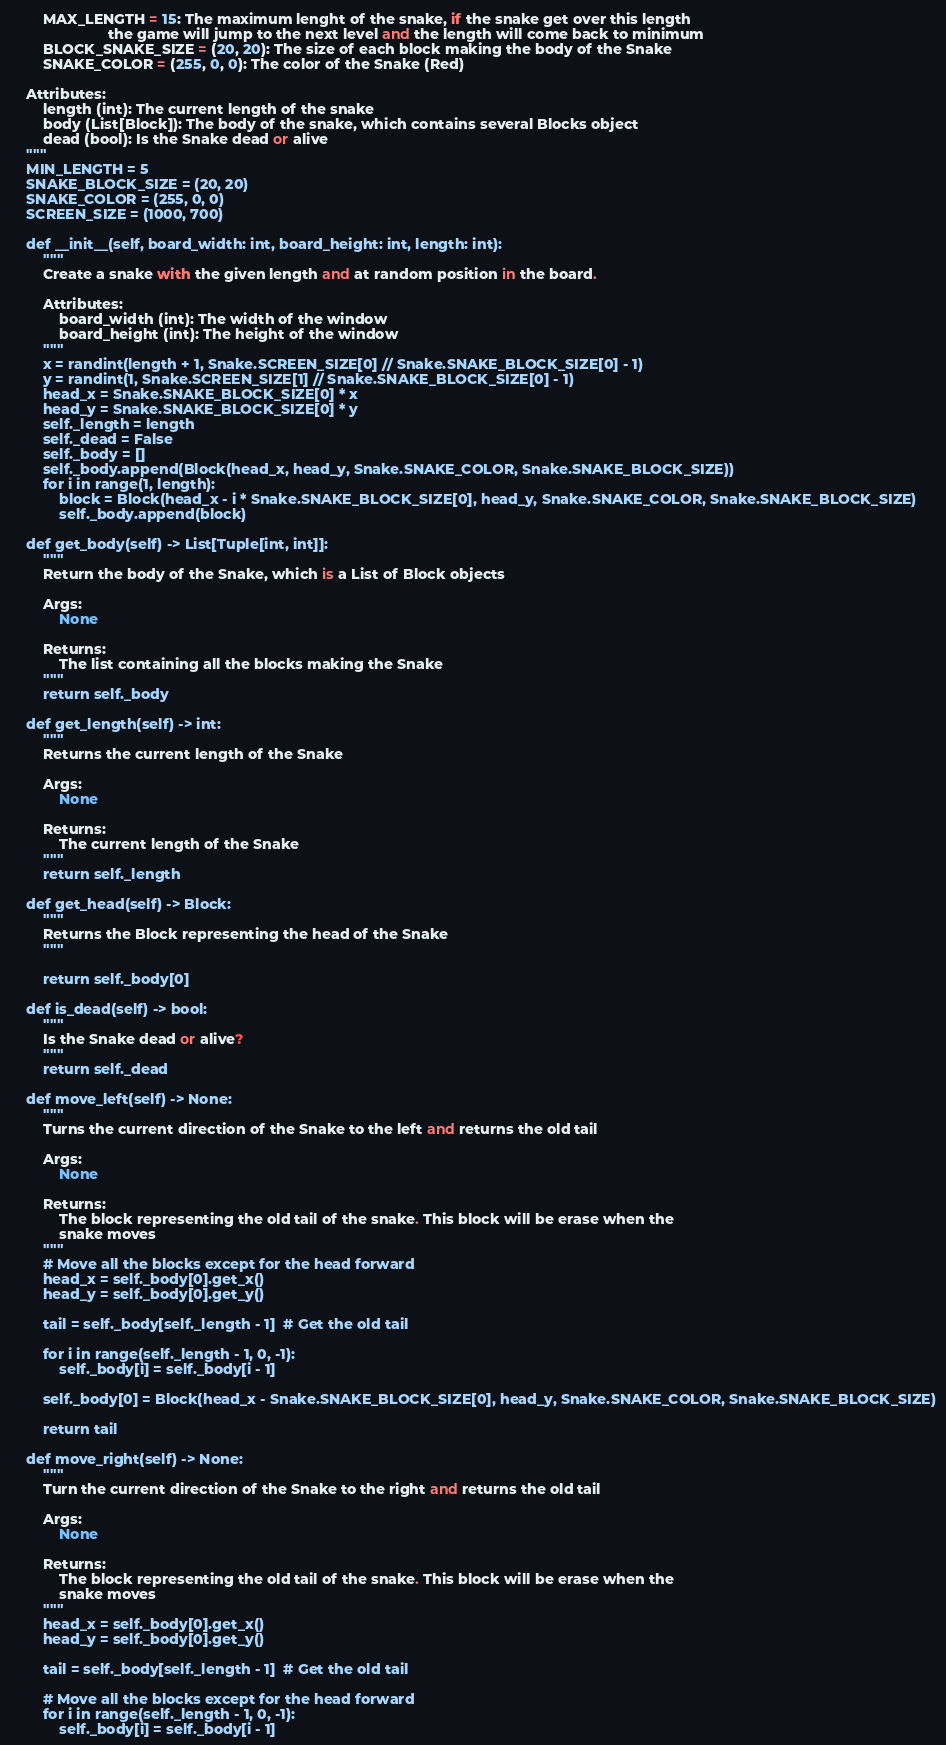<code> <loc_0><loc_0><loc_500><loc_500><_Python_>        MAX_LENGTH = 15: The maximum lenght of the snake, if the snake get over this length
                        the game will jump to the next level and the length will come back to minimum
        BLOCK_SNAKE_SIZE = (20, 20): The size of each block making the body of the Snake
        SNAKE_COLOR = (255, 0, 0): The color of the Snake (Red)

    Attributes:
        length (int): The current length of the snake
        body (List[Block]): The body of the snake, which contains several Blocks object
        dead (bool): Is the Snake dead or alive
    """
    MIN_LENGTH = 5
    SNAKE_BLOCK_SIZE = (20, 20)
    SNAKE_COLOR = (255, 0, 0)
    SCREEN_SIZE = (1000, 700)

    def __init__(self, board_width: int, board_height: int, length: int):
        """
        Create a snake with the given length and at random position in the board.

        Attributes:
            board_width (int): The width of the window
            board_height (int): The height of the window
        """
        x = randint(length + 1, Snake.SCREEN_SIZE[0] // Snake.SNAKE_BLOCK_SIZE[0] - 1)
        y = randint(1, Snake.SCREEN_SIZE[1] // Snake.SNAKE_BLOCK_SIZE[0] - 1)
        head_x = Snake.SNAKE_BLOCK_SIZE[0] * x
        head_y = Snake.SNAKE_BLOCK_SIZE[0] * y
        self._length = length
        self._dead = False
        self._body = []
        self._body.append(Block(head_x, head_y, Snake.SNAKE_COLOR, Snake.SNAKE_BLOCK_SIZE))
        for i in range(1, length):
            block = Block(head_x - i * Snake.SNAKE_BLOCK_SIZE[0], head_y, Snake.SNAKE_COLOR, Snake.SNAKE_BLOCK_SIZE)
            self._body.append(block)

    def get_body(self) -> List[Tuple[int, int]]:
        """
        Return the body of the Snake, which is a List of Block objects

        Args:
            None

        Returns:
            The list containing all the blocks making the Snake 
        """
        return self._body

    def get_length(self) -> int:
        """
        Returns the current length of the Snake

        Args:
            None

        Returns:   
            The current length of the Snake
        """
        return self._length

    def get_head(self) -> Block:
        """
        Returns the Block representing the head of the Snake
        """

        return self._body[0]

    def is_dead(self) -> bool:
        """
        Is the Snake dead or alive?
        """
        return self._dead

    def move_left(self) -> None:
        """
        Turns the current direction of the Snake to the left and returns the old tail

        Args:
            None

        Returns:
            The block representing the old tail of the snake. This block will be erase when the 
            snake moves
        """
        # Move all the blocks except for the head forward
        head_x = self._body[0].get_x()
        head_y = self._body[0].get_y()

        tail = self._body[self._length - 1]  # Get the old tail
        
        for i in range(self._length - 1, 0, -1):
            self._body[i] = self._body[i - 1]

        self._body[0] = Block(head_x - Snake.SNAKE_BLOCK_SIZE[0], head_y, Snake.SNAKE_COLOR, Snake.SNAKE_BLOCK_SIZE)

        return tail
    
    def move_right(self) -> None:
        """
        Turn the current direction of the Snake to the right and returns the old tail

        Args:
            None

        Returns:
            The block representing the old tail of the snake. This block will be erase when the 
            snake moves
        """
        head_x = self._body[0].get_x()
        head_y = self._body[0].get_y()

        tail = self._body[self._length - 1]  # Get the old tail

        # Move all the blocks except for the head forward
        for i in range(self._length - 1, 0, -1):
            self._body[i] = self._body[i - 1]
</code> 